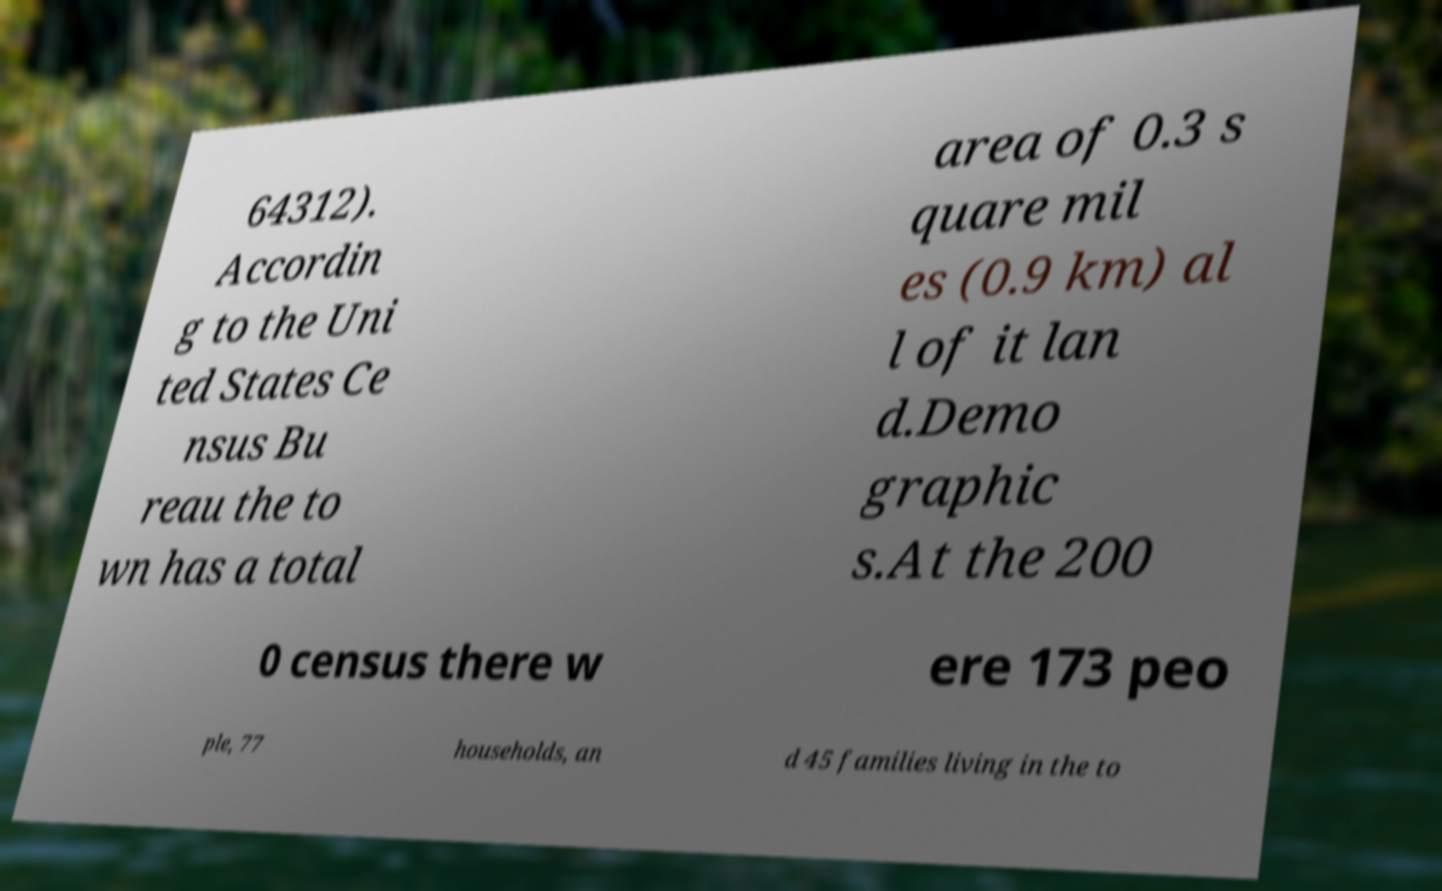I need the written content from this picture converted into text. Can you do that? 64312). Accordin g to the Uni ted States Ce nsus Bu reau the to wn has a total area of 0.3 s quare mil es (0.9 km) al l of it lan d.Demo graphic s.At the 200 0 census there w ere 173 peo ple, 77 households, an d 45 families living in the to 